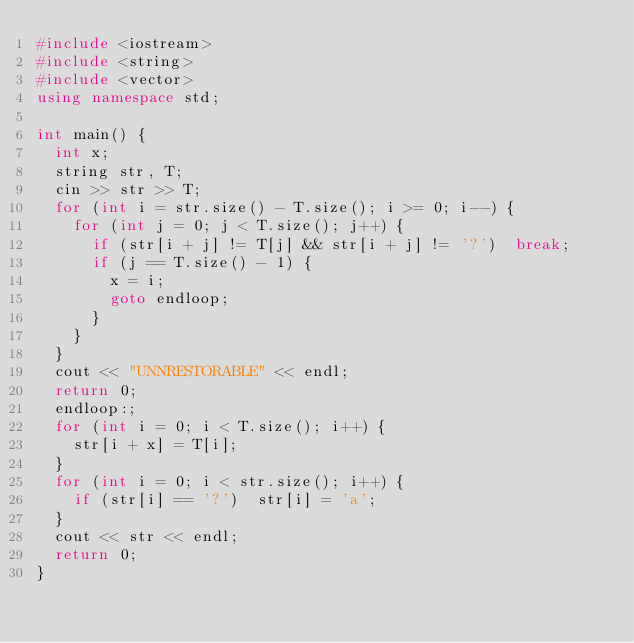<code> <loc_0><loc_0><loc_500><loc_500><_C++_>#include <iostream>
#include <string>
#include <vector>
using namespace std;

int main() {
	int x;
	string str, T;
	cin >> str >> T;
	for (int i = str.size() - T.size(); i >= 0; i--) {
		for (int j = 0; j < T.size(); j++) {
			if (str[i + j] != T[j] && str[i + j] != '?')	break;
			if (j == T.size() - 1) {
				x = i;
				goto endloop;
			}
		}
	}
	cout << "UNNRESTORABLE" << endl;
	return 0;
	endloop:;
	for (int i = 0; i < T.size(); i++) {
		str[i + x] = T[i];
	}
	for (int i = 0; i < str.size(); i++) {
		if (str[i] == '?')	str[i] = 'a';
	}
	cout << str << endl;
	return 0;
}</code> 